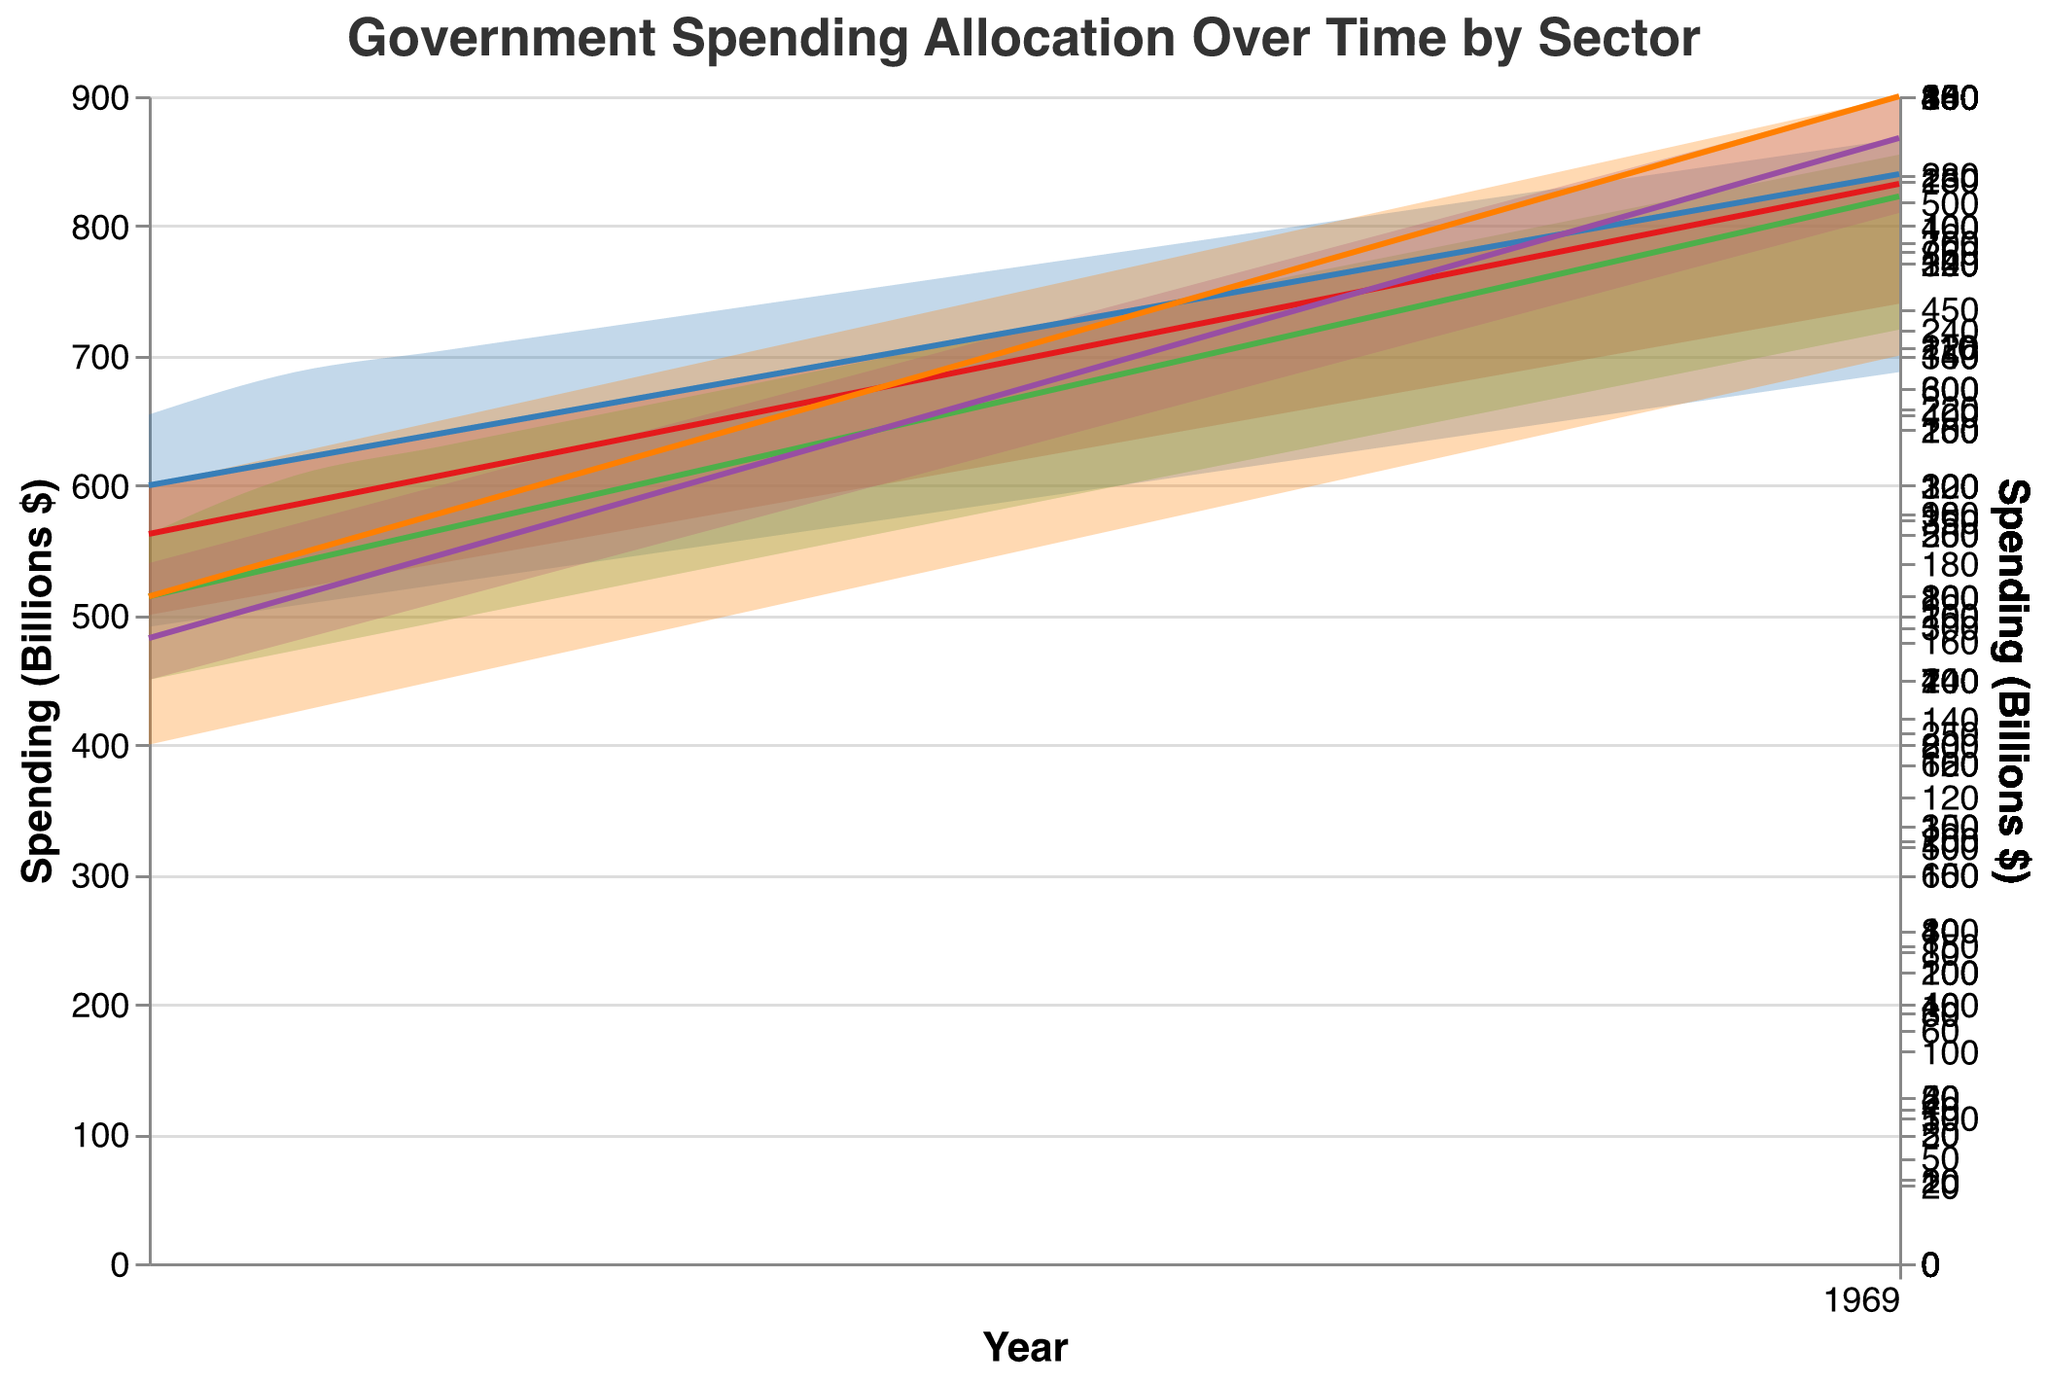What is the title of the chart? The title of the chart is at the top and reads "Government Spending Allocation Over Time by Sector".
Answer: Government Spending Allocation Over Time by Sector What is the minimum value of Defense Spending in 2015? The minimum value for Defense Spending in 2015 can be located by following the "Defense Spending Min" line to the year 2015, where the value is 600 billion dollars.
Answer: 600 Which sector had the highest spending range in 2022? The highest spending range is determined by the difference between the maximum and minimum spending values for each sector in 2022. For Defense, it is 840-740=100; for Healthcare, it is 530-420=110; for Education, it is 380-320=60; for Infrastructure, it is 300-270=30; and for Social Welfare, it is 180-140=40. The sector with the highest difference is Healthcare.
Answer: Healthcare What was the minimum Social Welfare spending in 2020? The minimum value for Social Welfare spending in 2020 can be identified by looking at the "Social Welfare Spending Min" value in the year 2020, which is 130 billion dollars.
Answer: 130 How does the range of Education Spending in 2014 compare to 2020? To find the range, subtract the minimum from the maximum spending for Education in both years. In 2014, it is 300-240=60, and in 2020, it is 360-300=60. The ranges for both years are equal.
Answer: Equal By how much did the maximum Healthcare spending increase from 2010 to 2022? To find the increase, subtract the maximum Healthcare spending in 2010 (400 billion dollars) from the maximum in 2022 (530 billion dollars), giving an increase of 530-400=130 billion dollars.
Answer: 130 Which sector had the smallest increase in minimum spending from 2010 to 2015? Calculate the increase for each sector from 2010 to 2015 by subtracting 2010's minimum value from 2015's minimum value. Defense: 600-500=100; Healthcare: 350-300=50; Education: 250-200=50; Infrastructure: 200-150=50; Social Welfare: 105-80=25. The smallest increase is in Social Welfare.
Answer: Social Welfare What is the trend of Infrastructure Spending from 2010 to 2022? Observing the "Infrastructure Spending Min" and "Infrastructure Spending Max" from 2010 to 2022, both minimum and maximum values are gradually increasing over the years, indicating a steady upward trend.
Answer: Steady upward trend 